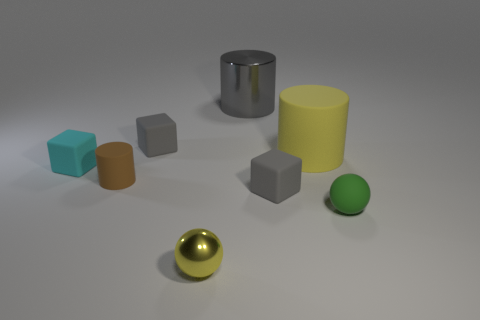How big is the gray block to the left of the yellow thing in front of the tiny green object? The gray block positioned to the left of the yellow cylinder and in front of the small green sphere appears to be a medium-sized object when compared to other items in the image. It is smaller than the yellow cylinder but larger than the little green object. 